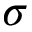Convert formula to latex. <formula><loc_0><loc_0><loc_500><loc_500>\sigma</formula> 